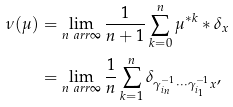Convert formula to latex. <formula><loc_0><loc_0><loc_500><loc_500>\nu ( \mu ) & = \lim _ { n \ a r r \infty } \frac { 1 } { n + 1 } \sum _ { k = 0 } ^ { n } \mu ^ { \ast k } \ast \delta _ { x } \\ & = \lim _ { n \ a r r \infty } \frac { 1 } { n } \sum _ { k = 1 } ^ { n } \delta _ { \gamma _ { i _ { n } } ^ { - 1 } \cdots \gamma _ { i _ { 1 } } ^ { - 1 } x } ,</formula> 